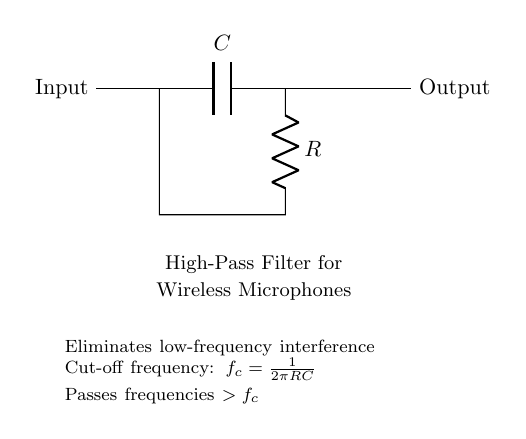What are the main components in this circuit? The circuit diagram shows a capacitor (C) and a resistor (R) as the main components of the high-pass filter. These components are clearly labeled in the diagram and are connected in tandem to create the filter effect.
Answer: capacitor and resistor What is the purpose of this filter? The filter's primary purpose is to eliminate low-frequency interference, which is indicated in the description below the circuit. It aims to pass only higher frequencies by blocking lower ones, ensuring a clear audio signal for the wireless microphones.
Answer: eliminate low-frequency interference What is the cut-off frequency formula? The formula provided in the explanation is cut-off frequency equals one divided by two pi times the product of resistance and capacitance (1/(2πRC)). This indicates how the cut-off frequency is calculated based on the values of the resistor and capacitor in the circuit.
Answer: 1/(2πRC) What happens to frequencies below the cut-off frequency? Frequencies below the cut-off frequency are blocked or attenuated by the high-pass filter, while higher frequencies are allowed to pass through. This functionality is essential for maintaining signal clarity in wireless applications.
Answer: blocked What type of filter is this circuit designed to be? This circuit is designed as a high-pass filter, as indicated in both the title and function mentioned in the diagram. It is specifically tailored to allow higher frequencies and reject lower frequency signals.
Answer: high-pass filter 